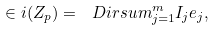Convert formula to latex. <formula><loc_0><loc_0><loc_500><loc_500>\in i ( Z _ { p } ) = \ D i r s u m _ { j = 1 } ^ { m } I _ { j } e _ { j } ,</formula> 